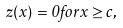Convert formula to latex. <formula><loc_0><loc_0><loc_500><loc_500>z ( x ) = 0 f o r x \geq c ,</formula> 